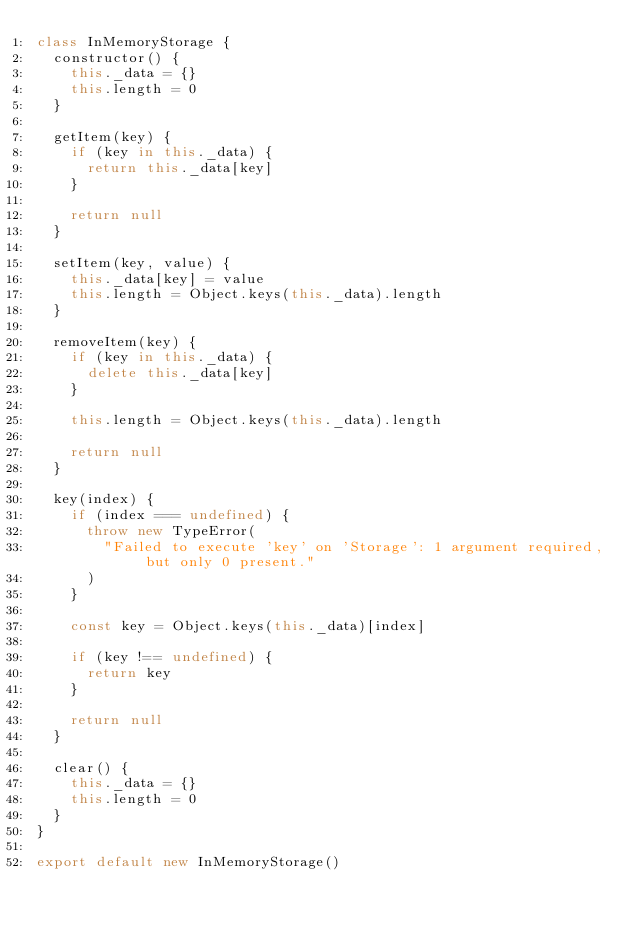<code> <loc_0><loc_0><loc_500><loc_500><_JavaScript_>class InMemoryStorage {
  constructor() {
    this._data = {}
    this.length = 0
  }

  getItem(key) {
    if (key in this._data) {
      return this._data[key]
    }

    return null
  }

  setItem(key, value) {
    this._data[key] = value
    this.length = Object.keys(this._data).length
  }

  removeItem(key) {
    if (key in this._data) {
      delete this._data[key]
    }

    this.length = Object.keys(this._data).length

    return null
  }

  key(index) {
    if (index === undefined) {
      throw new TypeError(
        "Failed to execute 'key' on 'Storage': 1 argument required, but only 0 present."
      )
    }

    const key = Object.keys(this._data)[index]

    if (key !== undefined) {
      return key
    }

    return null
  }

  clear() {
    this._data = {}
    this.length = 0
  }
}

export default new InMemoryStorage()
</code> 